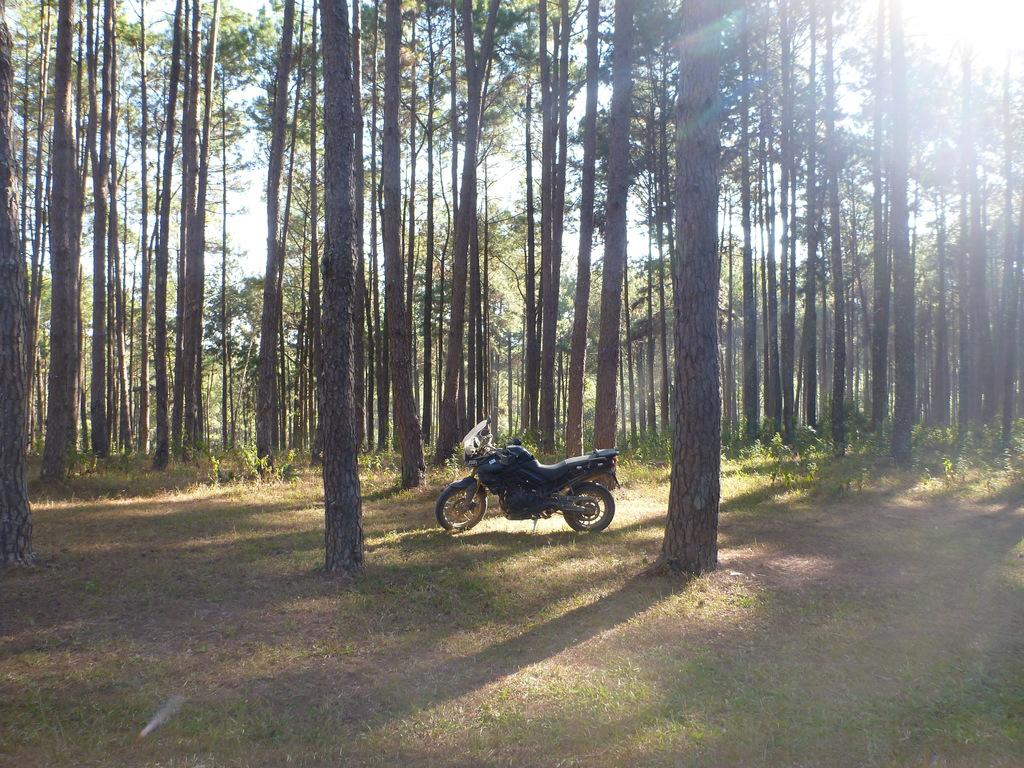What is the main object in the image? There is a bike in the image. How is the bike positioned in the image? The bike is parked on a side stand. Where is the bike located in the image? The bike is on the ground. What can be seen in the background of the image? There are trees, grass, plants, and the sky visible in the background of the image. What type of can is being used to water the plants in the image? There is no can present in the image, and no watering of plants is depicted. 